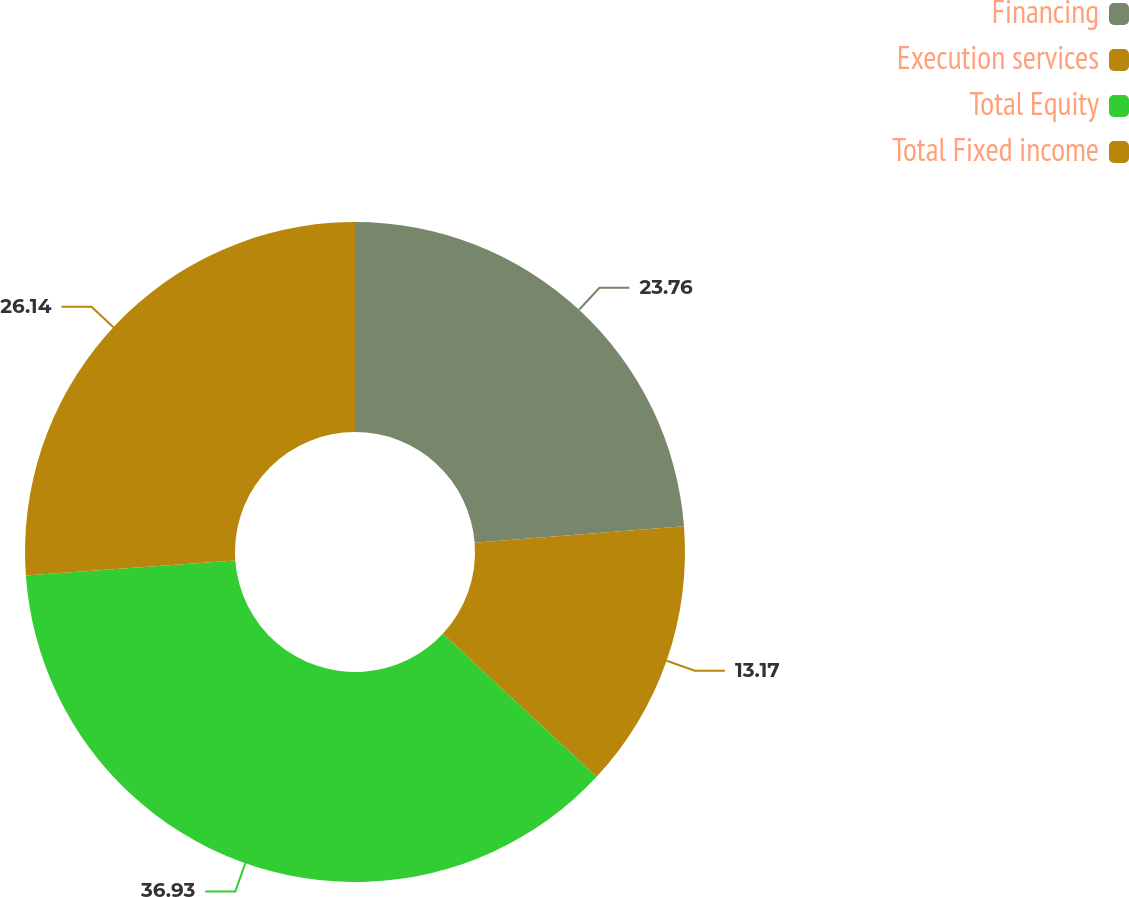Convert chart. <chart><loc_0><loc_0><loc_500><loc_500><pie_chart><fcel>Financing<fcel>Execution services<fcel>Total Equity<fcel>Total Fixed income<nl><fcel>23.76%<fcel>13.17%<fcel>36.93%<fcel>26.14%<nl></chart> 